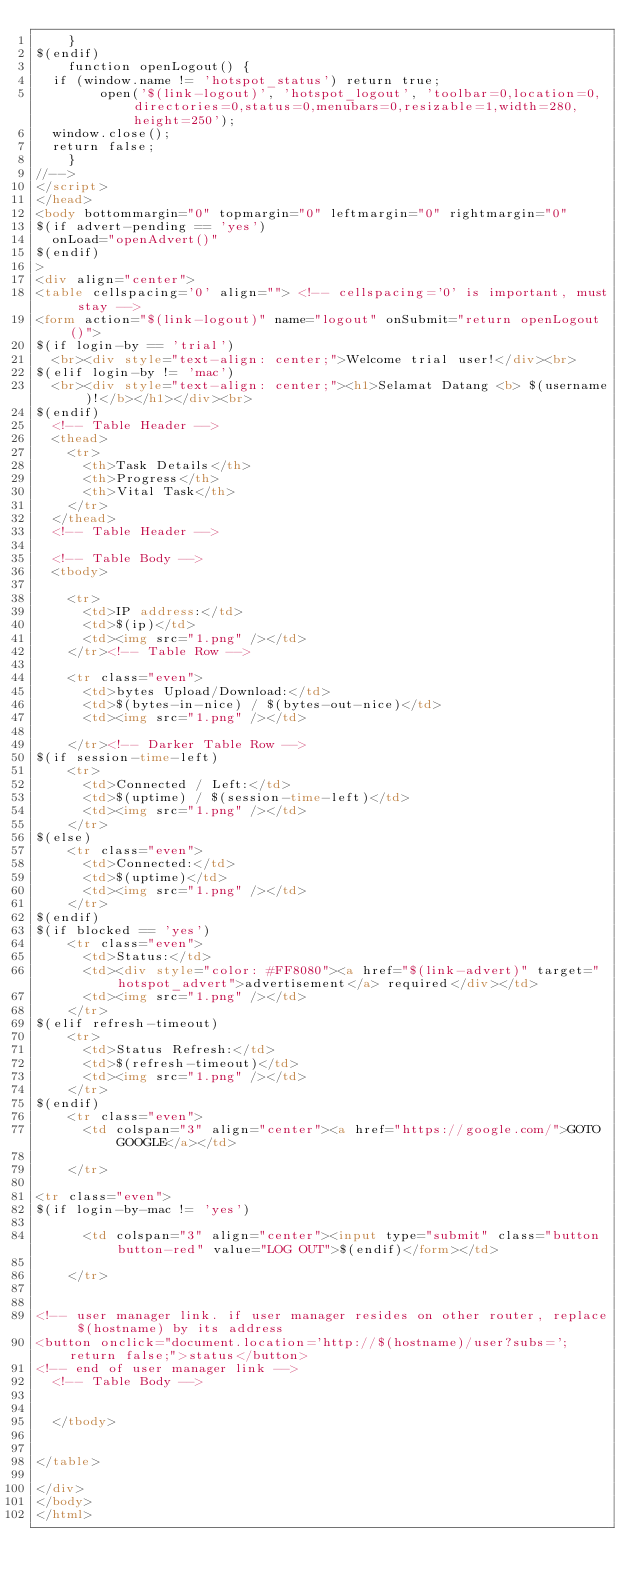Convert code to text. <code><loc_0><loc_0><loc_500><loc_500><_HTML_>    }
$(endif)
    function openLogout() {
	if (window.name != 'hotspot_status') return true;
        open('$(link-logout)', 'hotspot_logout', 'toolbar=0,location=0,directories=0,status=0,menubars=0,resizable=1,width=280,height=250');
	window.close();
	return false;
    }
//-->
</script>
</head>
<body bottommargin="0" topmargin="0" leftmargin="0" rightmargin="0"
$(if advert-pending == 'yes')
	onLoad="openAdvert()"
$(endif)
>
<div align="center">
<table cellspacing='0' align=""> <!-- cellspacing='0' is important, must stay -->
<form action="$(link-logout)" name="logout" onSubmit="return openLogout()">
$(if login-by == 'trial')
	<br><div style="text-align: center;">Welcome trial user!</div><br>
$(elif login-by != 'mac')
	<br><div style="text-align: center;"><h1>Selamat Datang <b> $(username)!</b></h1></div><br>
$(endif)
	<!-- Table Header -->
	<thead>
		<tr>
			<th>Task Details</th>
			<th>Progress</th>
			<th>Vital Task</th>
		</tr>
	</thead>
	<!-- Table Header -->

	<!-- Table Body -->
	<tbody>

		<tr>
			<td>IP address:</td>
			<td>$(ip)</td>
			<td><img src="1.png" /></td>
		</tr><!-- Table Row -->

		<tr class="even">
			<td>bytes Upload/Download:</td>
			<td>$(bytes-in-nice) / $(bytes-out-nice)</td>
			<td><img src="1.png" /></td>

		</tr><!-- Darker Table Row -->
$(if session-time-left)
		<tr>
			<td>Connected / Left:</td>
			<td>$(uptime) / $(session-time-left)</td>
			<td><img src="1.png" /></td>
		</tr>
$(else)
		<tr class="even">
			<td>Connected:</td>
			<td>$(uptime)</td>
			<td><img src="1.png" /></td>
		</tr>
$(endif)
$(if blocked == 'yes')
		<tr class="even">
			<td>Status:</td>
			<td><div style="color: #FF8080"><a href="$(link-advert)" target="hotspot_advert">advertisement</a> required</div></td>
			<td><img src="1.png" /></td>
		</tr>
$(elif refresh-timeout)
		<tr>
			<td>Status Refresh:</td>
			<td>$(refresh-timeout)</td>
			<td><img src="1.png" /></td>
		</tr>
$(endif)
		<tr class="even">
			<td colspan="3" align="center"><a href="https://google.com/">GOTO GOOGLE</a></td>
			
		</tr>

<tr class="even">
$(if login-by-mac != 'yes')
			
			<td colspan="3" align="center"><input type="submit" class="button button-red" value="LOG OUT">$(endif)</form></td>
			
		</tr>
        

<!-- user manager link. if user manager resides on other router, replace $(hostname) by its address
<button onclick="document.location='http://$(hostname)/user?subs='; return false;">status</button>
<!-- end of user manager link -->
	<!-- Table Body -->


	</tbody>


</table>

</div>
</body>
</html>
</code> 